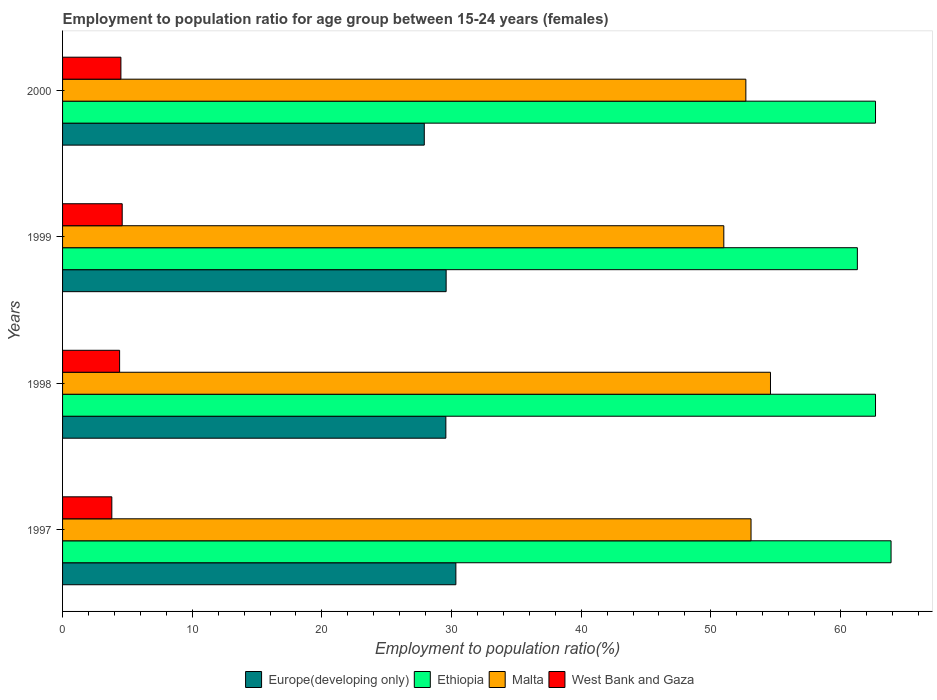How many different coloured bars are there?
Give a very brief answer. 4. How many groups of bars are there?
Make the answer very short. 4. Are the number of bars per tick equal to the number of legend labels?
Offer a terse response. Yes. How many bars are there on the 1st tick from the top?
Provide a succinct answer. 4. How many bars are there on the 2nd tick from the bottom?
Your answer should be compact. 4. In how many cases, is the number of bars for a given year not equal to the number of legend labels?
Your answer should be very brief. 0. What is the employment to population ratio in Malta in 1997?
Your answer should be very brief. 53.1. Across all years, what is the maximum employment to population ratio in Europe(developing only)?
Offer a terse response. 30.33. In which year was the employment to population ratio in Ethiopia maximum?
Your answer should be very brief. 1997. In which year was the employment to population ratio in West Bank and Gaza minimum?
Ensure brevity in your answer.  1997. What is the total employment to population ratio in Ethiopia in the graph?
Offer a very short reply. 250.6. What is the difference between the employment to population ratio in Europe(developing only) in 2000 and the employment to population ratio in West Bank and Gaza in 1998?
Make the answer very short. 23.5. What is the average employment to population ratio in Europe(developing only) per year?
Your answer should be compact. 29.34. In the year 1999, what is the difference between the employment to population ratio in Europe(developing only) and employment to population ratio in Malta?
Your response must be concise. -21.42. In how many years, is the employment to population ratio in Ethiopia greater than 40 %?
Provide a short and direct response. 4. What is the ratio of the employment to population ratio in West Bank and Gaza in 1998 to that in 1999?
Provide a succinct answer. 0.96. Is the difference between the employment to population ratio in Europe(developing only) in 1997 and 2000 greater than the difference between the employment to population ratio in Malta in 1997 and 2000?
Your response must be concise. Yes. What is the difference between the highest and the lowest employment to population ratio in Malta?
Provide a succinct answer. 3.6. In how many years, is the employment to population ratio in West Bank and Gaza greater than the average employment to population ratio in West Bank and Gaza taken over all years?
Your answer should be very brief. 3. What does the 1st bar from the top in 1997 represents?
Keep it short and to the point. West Bank and Gaza. What does the 2nd bar from the bottom in 2000 represents?
Give a very brief answer. Ethiopia. How many years are there in the graph?
Ensure brevity in your answer.  4. Does the graph contain grids?
Your response must be concise. No. How are the legend labels stacked?
Keep it short and to the point. Horizontal. What is the title of the graph?
Your answer should be compact. Employment to population ratio for age group between 15-24 years (females). What is the label or title of the X-axis?
Your answer should be very brief. Employment to population ratio(%). What is the Employment to population ratio(%) in Europe(developing only) in 1997?
Your answer should be compact. 30.33. What is the Employment to population ratio(%) of Ethiopia in 1997?
Ensure brevity in your answer.  63.9. What is the Employment to population ratio(%) in Malta in 1997?
Your response must be concise. 53.1. What is the Employment to population ratio(%) of West Bank and Gaza in 1997?
Your response must be concise. 3.8. What is the Employment to population ratio(%) of Europe(developing only) in 1998?
Your answer should be compact. 29.56. What is the Employment to population ratio(%) in Ethiopia in 1998?
Make the answer very short. 62.7. What is the Employment to population ratio(%) of Malta in 1998?
Your response must be concise. 54.6. What is the Employment to population ratio(%) in West Bank and Gaza in 1998?
Provide a short and direct response. 4.4. What is the Employment to population ratio(%) of Europe(developing only) in 1999?
Offer a terse response. 29.58. What is the Employment to population ratio(%) in Ethiopia in 1999?
Your answer should be very brief. 61.3. What is the Employment to population ratio(%) in West Bank and Gaza in 1999?
Your response must be concise. 4.6. What is the Employment to population ratio(%) in Europe(developing only) in 2000?
Give a very brief answer. 27.9. What is the Employment to population ratio(%) of Ethiopia in 2000?
Your response must be concise. 62.7. What is the Employment to population ratio(%) of Malta in 2000?
Your response must be concise. 52.7. Across all years, what is the maximum Employment to population ratio(%) in Europe(developing only)?
Your response must be concise. 30.33. Across all years, what is the maximum Employment to population ratio(%) in Ethiopia?
Make the answer very short. 63.9. Across all years, what is the maximum Employment to population ratio(%) of Malta?
Make the answer very short. 54.6. Across all years, what is the maximum Employment to population ratio(%) in West Bank and Gaza?
Provide a succinct answer. 4.6. Across all years, what is the minimum Employment to population ratio(%) in Europe(developing only)?
Your response must be concise. 27.9. Across all years, what is the minimum Employment to population ratio(%) of Ethiopia?
Your answer should be very brief. 61.3. Across all years, what is the minimum Employment to population ratio(%) of West Bank and Gaza?
Offer a very short reply. 3.8. What is the total Employment to population ratio(%) of Europe(developing only) in the graph?
Ensure brevity in your answer.  117.38. What is the total Employment to population ratio(%) in Ethiopia in the graph?
Make the answer very short. 250.6. What is the total Employment to population ratio(%) of Malta in the graph?
Ensure brevity in your answer.  211.4. What is the total Employment to population ratio(%) of West Bank and Gaza in the graph?
Your answer should be compact. 17.3. What is the difference between the Employment to population ratio(%) in Europe(developing only) in 1997 and that in 1998?
Make the answer very short. 0.77. What is the difference between the Employment to population ratio(%) of West Bank and Gaza in 1997 and that in 1998?
Ensure brevity in your answer.  -0.6. What is the difference between the Employment to population ratio(%) of Europe(developing only) in 1997 and that in 1999?
Make the answer very short. 0.75. What is the difference between the Employment to population ratio(%) in Malta in 1997 and that in 1999?
Provide a short and direct response. 2.1. What is the difference between the Employment to population ratio(%) of West Bank and Gaza in 1997 and that in 1999?
Keep it short and to the point. -0.8. What is the difference between the Employment to population ratio(%) in Europe(developing only) in 1997 and that in 2000?
Offer a very short reply. 2.44. What is the difference between the Employment to population ratio(%) of West Bank and Gaza in 1997 and that in 2000?
Ensure brevity in your answer.  -0.7. What is the difference between the Employment to population ratio(%) in Europe(developing only) in 1998 and that in 1999?
Your answer should be compact. -0.02. What is the difference between the Employment to population ratio(%) of Ethiopia in 1998 and that in 1999?
Provide a succinct answer. 1.4. What is the difference between the Employment to population ratio(%) in Malta in 1998 and that in 1999?
Make the answer very short. 3.6. What is the difference between the Employment to population ratio(%) in Europe(developing only) in 1998 and that in 2000?
Your answer should be very brief. 1.66. What is the difference between the Employment to population ratio(%) in West Bank and Gaza in 1998 and that in 2000?
Your response must be concise. -0.1. What is the difference between the Employment to population ratio(%) of Europe(developing only) in 1999 and that in 2000?
Ensure brevity in your answer.  1.69. What is the difference between the Employment to population ratio(%) in Malta in 1999 and that in 2000?
Your answer should be very brief. -1.7. What is the difference between the Employment to population ratio(%) in West Bank and Gaza in 1999 and that in 2000?
Your response must be concise. 0.1. What is the difference between the Employment to population ratio(%) of Europe(developing only) in 1997 and the Employment to population ratio(%) of Ethiopia in 1998?
Your answer should be compact. -32.37. What is the difference between the Employment to population ratio(%) in Europe(developing only) in 1997 and the Employment to population ratio(%) in Malta in 1998?
Offer a terse response. -24.27. What is the difference between the Employment to population ratio(%) in Europe(developing only) in 1997 and the Employment to population ratio(%) in West Bank and Gaza in 1998?
Give a very brief answer. 25.93. What is the difference between the Employment to population ratio(%) in Ethiopia in 1997 and the Employment to population ratio(%) in West Bank and Gaza in 1998?
Give a very brief answer. 59.5. What is the difference between the Employment to population ratio(%) of Malta in 1997 and the Employment to population ratio(%) of West Bank and Gaza in 1998?
Keep it short and to the point. 48.7. What is the difference between the Employment to population ratio(%) of Europe(developing only) in 1997 and the Employment to population ratio(%) of Ethiopia in 1999?
Give a very brief answer. -30.97. What is the difference between the Employment to population ratio(%) in Europe(developing only) in 1997 and the Employment to population ratio(%) in Malta in 1999?
Your answer should be compact. -20.67. What is the difference between the Employment to population ratio(%) in Europe(developing only) in 1997 and the Employment to population ratio(%) in West Bank and Gaza in 1999?
Provide a succinct answer. 25.73. What is the difference between the Employment to population ratio(%) of Ethiopia in 1997 and the Employment to population ratio(%) of West Bank and Gaza in 1999?
Make the answer very short. 59.3. What is the difference between the Employment to population ratio(%) of Malta in 1997 and the Employment to population ratio(%) of West Bank and Gaza in 1999?
Make the answer very short. 48.5. What is the difference between the Employment to population ratio(%) of Europe(developing only) in 1997 and the Employment to population ratio(%) of Ethiopia in 2000?
Provide a succinct answer. -32.37. What is the difference between the Employment to population ratio(%) in Europe(developing only) in 1997 and the Employment to population ratio(%) in Malta in 2000?
Provide a short and direct response. -22.37. What is the difference between the Employment to population ratio(%) of Europe(developing only) in 1997 and the Employment to population ratio(%) of West Bank and Gaza in 2000?
Ensure brevity in your answer.  25.83. What is the difference between the Employment to population ratio(%) of Ethiopia in 1997 and the Employment to population ratio(%) of Malta in 2000?
Provide a short and direct response. 11.2. What is the difference between the Employment to population ratio(%) in Ethiopia in 1997 and the Employment to population ratio(%) in West Bank and Gaza in 2000?
Offer a terse response. 59.4. What is the difference between the Employment to population ratio(%) in Malta in 1997 and the Employment to population ratio(%) in West Bank and Gaza in 2000?
Provide a short and direct response. 48.6. What is the difference between the Employment to population ratio(%) in Europe(developing only) in 1998 and the Employment to population ratio(%) in Ethiopia in 1999?
Your answer should be very brief. -31.74. What is the difference between the Employment to population ratio(%) in Europe(developing only) in 1998 and the Employment to population ratio(%) in Malta in 1999?
Make the answer very short. -21.44. What is the difference between the Employment to population ratio(%) in Europe(developing only) in 1998 and the Employment to population ratio(%) in West Bank and Gaza in 1999?
Offer a very short reply. 24.96. What is the difference between the Employment to population ratio(%) of Ethiopia in 1998 and the Employment to population ratio(%) of Malta in 1999?
Ensure brevity in your answer.  11.7. What is the difference between the Employment to population ratio(%) in Ethiopia in 1998 and the Employment to population ratio(%) in West Bank and Gaza in 1999?
Your answer should be very brief. 58.1. What is the difference between the Employment to population ratio(%) of Europe(developing only) in 1998 and the Employment to population ratio(%) of Ethiopia in 2000?
Ensure brevity in your answer.  -33.14. What is the difference between the Employment to population ratio(%) in Europe(developing only) in 1998 and the Employment to population ratio(%) in Malta in 2000?
Provide a succinct answer. -23.14. What is the difference between the Employment to population ratio(%) of Europe(developing only) in 1998 and the Employment to population ratio(%) of West Bank and Gaza in 2000?
Provide a succinct answer. 25.06. What is the difference between the Employment to population ratio(%) of Ethiopia in 1998 and the Employment to population ratio(%) of Malta in 2000?
Provide a short and direct response. 10. What is the difference between the Employment to population ratio(%) of Ethiopia in 1998 and the Employment to population ratio(%) of West Bank and Gaza in 2000?
Provide a succinct answer. 58.2. What is the difference between the Employment to population ratio(%) of Malta in 1998 and the Employment to population ratio(%) of West Bank and Gaza in 2000?
Ensure brevity in your answer.  50.1. What is the difference between the Employment to population ratio(%) of Europe(developing only) in 1999 and the Employment to population ratio(%) of Ethiopia in 2000?
Make the answer very short. -33.12. What is the difference between the Employment to population ratio(%) in Europe(developing only) in 1999 and the Employment to population ratio(%) in Malta in 2000?
Your answer should be compact. -23.12. What is the difference between the Employment to population ratio(%) of Europe(developing only) in 1999 and the Employment to population ratio(%) of West Bank and Gaza in 2000?
Provide a succinct answer. 25.08. What is the difference between the Employment to population ratio(%) in Ethiopia in 1999 and the Employment to population ratio(%) in Malta in 2000?
Give a very brief answer. 8.6. What is the difference between the Employment to population ratio(%) in Ethiopia in 1999 and the Employment to population ratio(%) in West Bank and Gaza in 2000?
Offer a very short reply. 56.8. What is the difference between the Employment to population ratio(%) of Malta in 1999 and the Employment to population ratio(%) of West Bank and Gaza in 2000?
Your answer should be compact. 46.5. What is the average Employment to population ratio(%) in Europe(developing only) per year?
Provide a succinct answer. 29.34. What is the average Employment to population ratio(%) of Ethiopia per year?
Offer a terse response. 62.65. What is the average Employment to population ratio(%) in Malta per year?
Provide a short and direct response. 52.85. What is the average Employment to population ratio(%) in West Bank and Gaza per year?
Make the answer very short. 4.33. In the year 1997, what is the difference between the Employment to population ratio(%) of Europe(developing only) and Employment to population ratio(%) of Ethiopia?
Your answer should be compact. -33.57. In the year 1997, what is the difference between the Employment to population ratio(%) of Europe(developing only) and Employment to population ratio(%) of Malta?
Your answer should be compact. -22.77. In the year 1997, what is the difference between the Employment to population ratio(%) of Europe(developing only) and Employment to population ratio(%) of West Bank and Gaza?
Your answer should be very brief. 26.53. In the year 1997, what is the difference between the Employment to population ratio(%) in Ethiopia and Employment to population ratio(%) in West Bank and Gaza?
Offer a terse response. 60.1. In the year 1997, what is the difference between the Employment to population ratio(%) of Malta and Employment to population ratio(%) of West Bank and Gaza?
Make the answer very short. 49.3. In the year 1998, what is the difference between the Employment to population ratio(%) of Europe(developing only) and Employment to population ratio(%) of Ethiopia?
Provide a succinct answer. -33.14. In the year 1998, what is the difference between the Employment to population ratio(%) in Europe(developing only) and Employment to population ratio(%) in Malta?
Provide a short and direct response. -25.04. In the year 1998, what is the difference between the Employment to population ratio(%) of Europe(developing only) and Employment to population ratio(%) of West Bank and Gaza?
Provide a short and direct response. 25.16. In the year 1998, what is the difference between the Employment to population ratio(%) of Ethiopia and Employment to population ratio(%) of Malta?
Give a very brief answer. 8.1. In the year 1998, what is the difference between the Employment to population ratio(%) of Ethiopia and Employment to population ratio(%) of West Bank and Gaza?
Offer a terse response. 58.3. In the year 1998, what is the difference between the Employment to population ratio(%) in Malta and Employment to population ratio(%) in West Bank and Gaza?
Your answer should be compact. 50.2. In the year 1999, what is the difference between the Employment to population ratio(%) of Europe(developing only) and Employment to population ratio(%) of Ethiopia?
Make the answer very short. -31.72. In the year 1999, what is the difference between the Employment to population ratio(%) in Europe(developing only) and Employment to population ratio(%) in Malta?
Offer a terse response. -21.42. In the year 1999, what is the difference between the Employment to population ratio(%) in Europe(developing only) and Employment to population ratio(%) in West Bank and Gaza?
Offer a terse response. 24.98. In the year 1999, what is the difference between the Employment to population ratio(%) in Ethiopia and Employment to population ratio(%) in West Bank and Gaza?
Provide a succinct answer. 56.7. In the year 1999, what is the difference between the Employment to population ratio(%) in Malta and Employment to population ratio(%) in West Bank and Gaza?
Provide a short and direct response. 46.4. In the year 2000, what is the difference between the Employment to population ratio(%) in Europe(developing only) and Employment to population ratio(%) in Ethiopia?
Your answer should be compact. -34.8. In the year 2000, what is the difference between the Employment to population ratio(%) in Europe(developing only) and Employment to population ratio(%) in Malta?
Offer a very short reply. -24.8. In the year 2000, what is the difference between the Employment to population ratio(%) in Europe(developing only) and Employment to population ratio(%) in West Bank and Gaza?
Provide a succinct answer. 23.4. In the year 2000, what is the difference between the Employment to population ratio(%) in Ethiopia and Employment to population ratio(%) in Malta?
Your answer should be very brief. 10. In the year 2000, what is the difference between the Employment to population ratio(%) of Ethiopia and Employment to population ratio(%) of West Bank and Gaza?
Keep it short and to the point. 58.2. In the year 2000, what is the difference between the Employment to population ratio(%) in Malta and Employment to population ratio(%) in West Bank and Gaza?
Provide a short and direct response. 48.2. What is the ratio of the Employment to population ratio(%) in Europe(developing only) in 1997 to that in 1998?
Offer a terse response. 1.03. What is the ratio of the Employment to population ratio(%) in Ethiopia in 1997 to that in 1998?
Provide a short and direct response. 1.02. What is the ratio of the Employment to population ratio(%) of Malta in 1997 to that in 1998?
Provide a short and direct response. 0.97. What is the ratio of the Employment to population ratio(%) in West Bank and Gaza in 1997 to that in 1998?
Provide a succinct answer. 0.86. What is the ratio of the Employment to population ratio(%) in Europe(developing only) in 1997 to that in 1999?
Offer a terse response. 1.03. What is the ratio of the Employment to population ratio(%) in Ethiopia in 1997 to that in 1999?
Your answer should be very brief. 1.04. What is the ratio of the Employment to population ratio(%) of Malta in 1997 to that in 1999?
Your answer should be compact. 1.04. What is the ratio of the Employment to population ratio(%) of West Bank and Gaza in 1997 to that in 1999?
Make the answer very short. 0.83. What is the ratio of the Employment to population ratio(%) of Europe(developing only) in 1997 to that in 2000?
Ensure brevity in your answer.  1.09. What is the ratio of the Employment to population ratio(%) in Ethiopia in 1997 to that in 2000?
Offer a very short reply. 1.02. What is the ratio of the Employment to population ratio(%) in Malta in 1997 to that in 2000?
Offer a very short reply. 1.01. What is the ratio of the Employment to population ratio(%) of West Bank and Gaza in 1997 to that in 2000?
Provide a short and direct response. 0.84. What is the ratio of the Employment to population ratio(%) in Ethiopia in 1998 to that in 1999?
Keep it short and to the point. 1.02. What is the ratio of the Employment to population ratio(%) in Malta in 1998 to that in 1999?
Ensure brevity in your answer.  1.07. What is the ratio of the Employment to population ratio(%) in West Bank and Gaza in 1998 to that in 1999?
Provide a short and direct response. 0.96. What is the ratio of the Employment to population ratio(%) in Europe(developing only) in 1998 to that in 2000?
Your response must be concise. 1.06. What is the ratio of the Employment to population ratio(%) in Ethiopia in 1998 to that in 2000?
Your answer should be very brief. 1. What is the ratio of the Employment to population ratio(%) in Malta in 1998 to that in 2000?
Keep it short and to the point. 1.04. What is the ratio of the Employment to population ratio(%) in West Bank and Gaza in 1998 to that in 2000?
Your answer should be compact. 0.98. What is the ratio of the Employment to population ratio(%) in Europe(developing only) in 1999 to that in 2000?
Provide a succinct answer. 1.06. What is the ratio of the Employment to population ratio(%) of Ethiopia in 1999 to that in 2000?
Offer a very short reply. 0.98. What is the ratio of the Employment to population ratio(%) of Malta in 1999 to that in 2000?
Make the answer very short. 0.97. What is the ratio of the Employment to population ratio(%) in West Bank and Gaza in 1999 to that in 2000?
Ensure brevity in your answer.  1.02. What is the difference between the highest and the second highest Employment to population ratio(%) in Europe(developing only)?
Your answer should be compact. 0.75. What is the difference between the highest and the second highest Employment to population ratio(%) of Ethiopia?
Offer a very short reply. 1.2. What is the difference between the highest and the lowest Employment to population ratio(%) of Europe(developing only)?
Give a very brief answer. 2.44. What is the difference between the highest and the lowest Employment to population ratio(%) in Malta?
Ensure brevity in your answer.  3.6. 